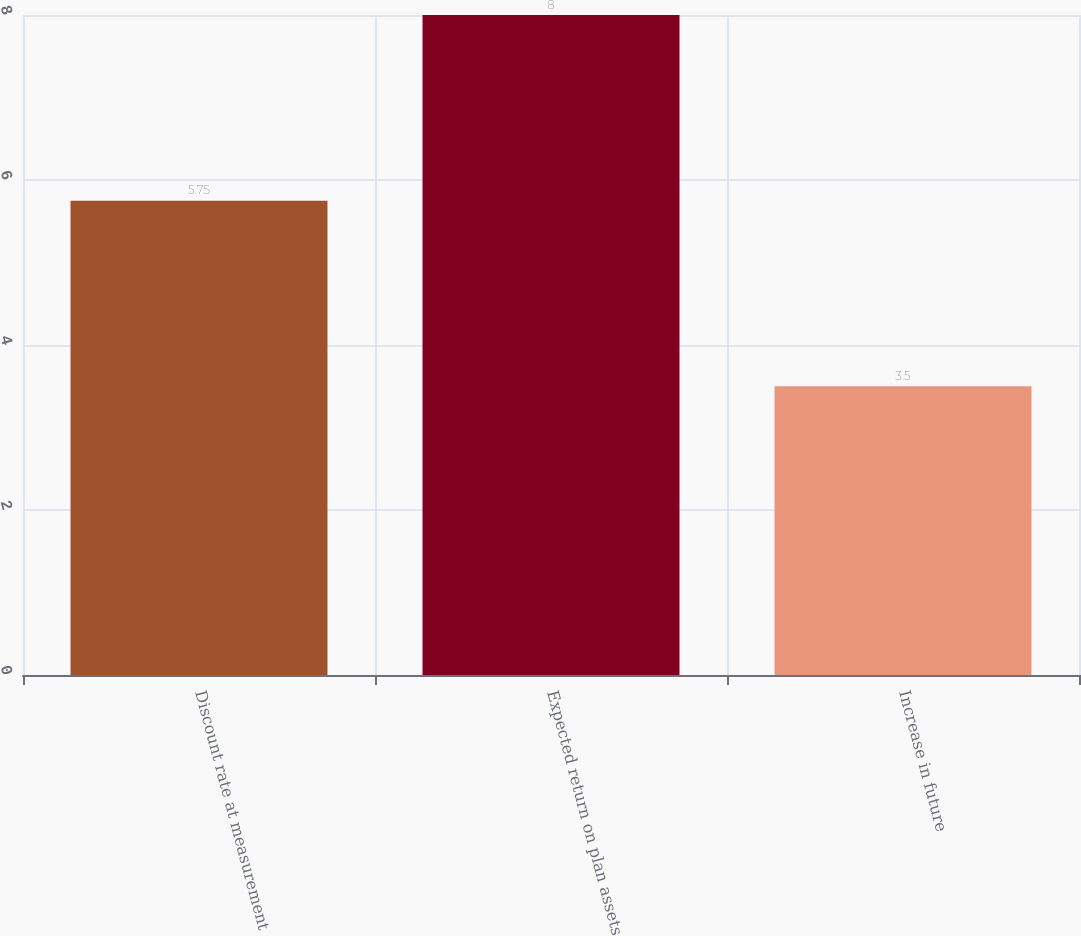<chart> <loc_0><loc_0><loc_500><loc_500><bar_chart><fcel>Discount rate at measurement<fcel>Expected return on plan assets<fcel>Increase in future<nl><fcel>5.75<fcel>8<fcel>3.5<nl></chart> 